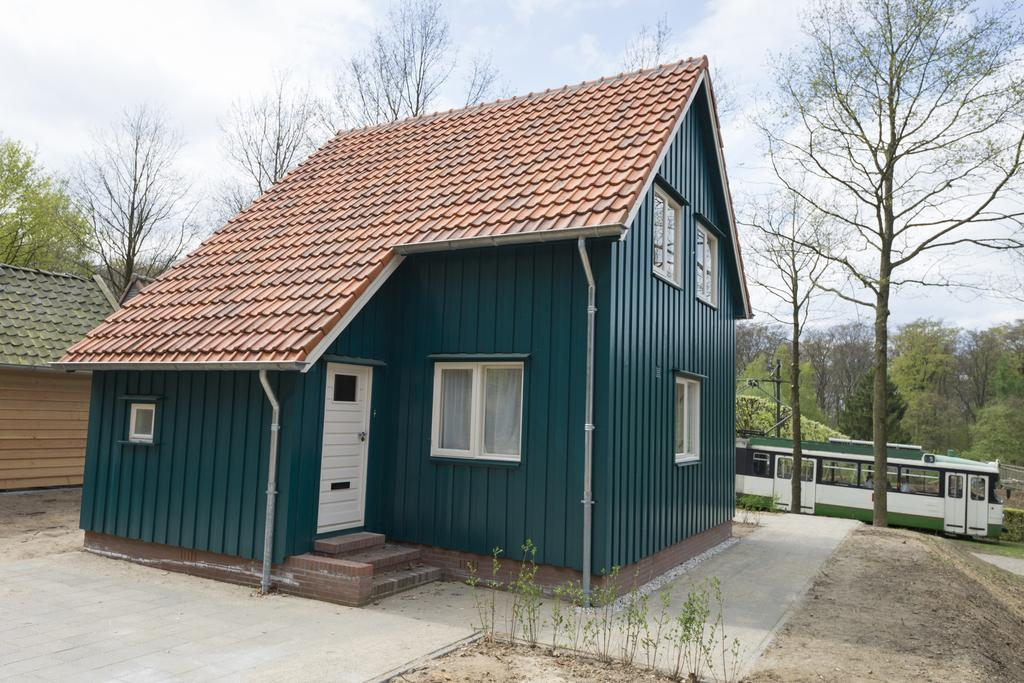What is the main structure in the center of the image? There is a home in the center of the image. What can be seen in the background of the image? There is a bus and trees in the background of the image. How would you describe the weather in the image? The sky is cloudy in the image, suggesting a potentially overcast or rainy day. What is located on the left side of the image? There is a hut on the left side of the image. What type of vest is the home wearing in the image? Homes do not wear vests, as they are inanimate objects. 